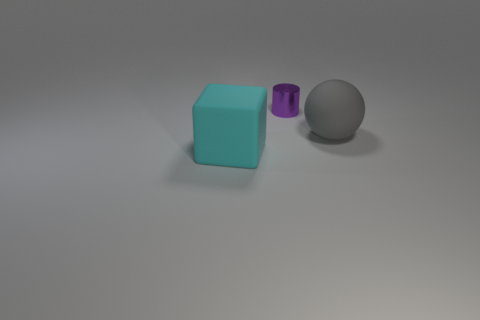Are these objects arranged in a particular way or pattern? The objects are arranged sequentially in a diagonal line with equal spacing, running from the bottom left to the top right of the frame. This configuration creates a pleasant visual line for the eye to follow and emphasizes the differences in shapes and sizes of the three objects. 